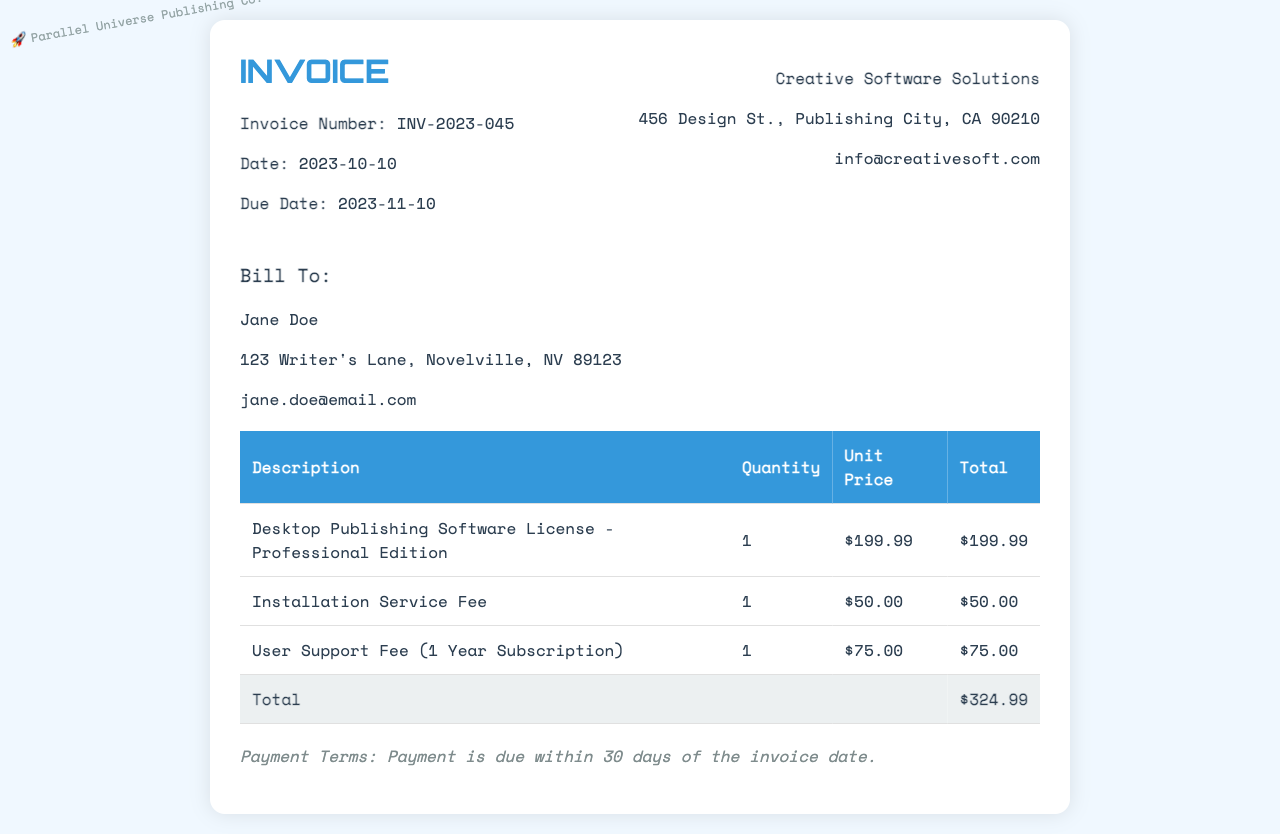What is the invoice number? The invoice number is explicitly listed in the document as INV-2023-045.
Answer: INV-2023-045 Who is the billing recipient? The billing recipient's name is given in the document as Jane Doe.
Answer: Jane Doe What is the date of the invoice? The date of the invoice is clearly stated in the document as 2023-10-10.
Answer: 2023-10-10 What is the total amount due? The total amount due, found at the bottom of the invoice, is $324.99.
Answer: $324.99 How much is the installation service fee? The installation service fee is specified in the table as $50.00.
Answer: $50.00 What is the duration of the user support fee? The user support fee is associated with a subscription for 1 year, as indicated in the document.
Answer: 1 Year When is the payment due? The due date for payment is indicated in the document as 2023-11-10.
Answer: 2023-11-10 What is the unit price of the desktop publishing software license? The unit price of the desktop publishing software license is shown as $199.99 in the invoice.
Answer: $199.99 What company issued the invoice? The issuing company is identified in the document as Creative Software Solutions.
Answer: Creative Software Solutions 